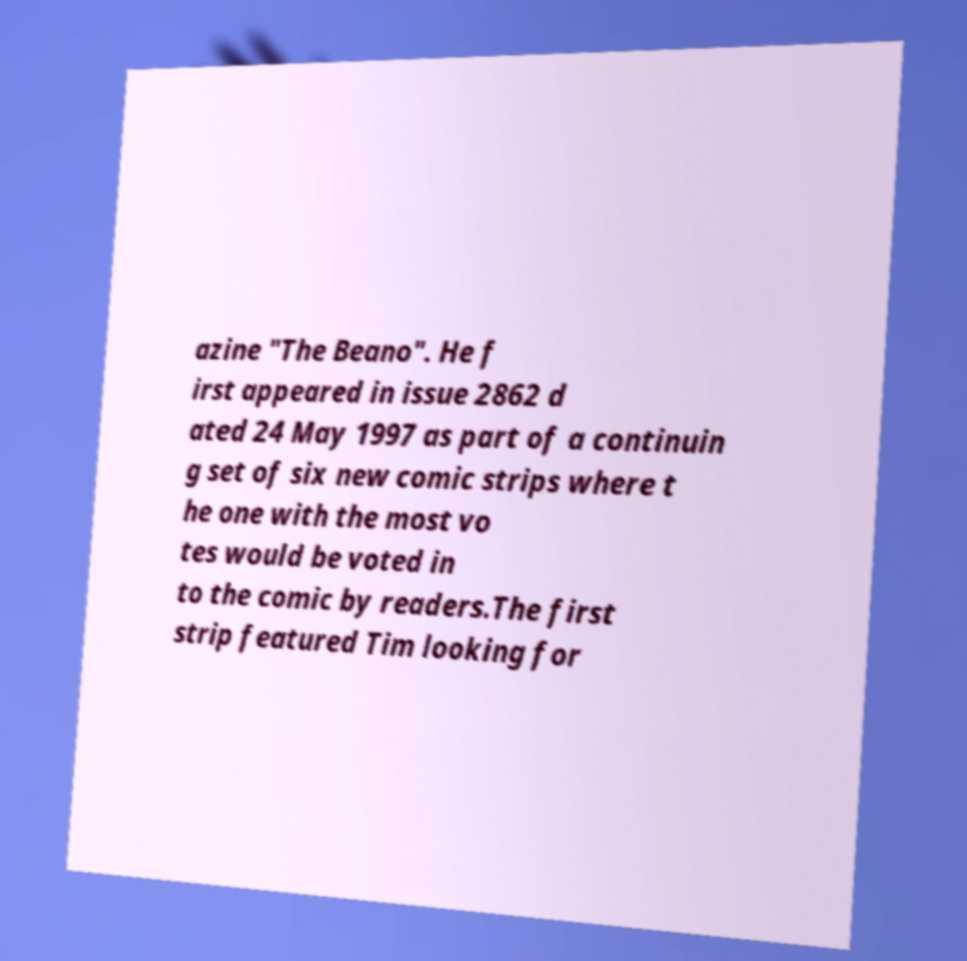There's text embedded in this image that I need extracted. Can you transcribe it verbatim? azine "The Beano". He f irst appeared in issue 2862 d ated 24 May 1997 as part of a continuin g set of six new comic strips where t he one with the most vo tes would be voted in to the comic by readers.The first strip featured Tim looking for 